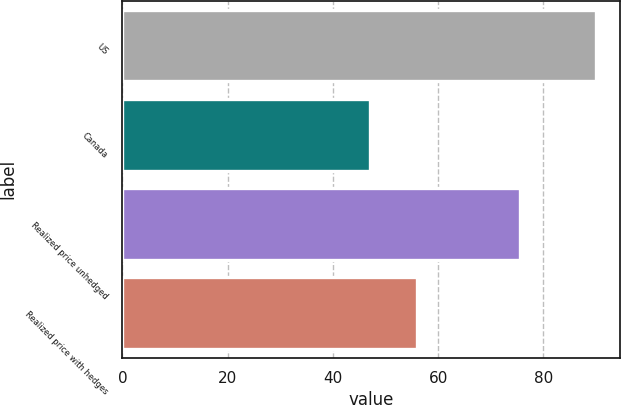Convert chart to OTSL. <chart><loc_0><loc_0><loc_500><loc_500><bar_chart><fcel>US<fcel>Canada<fcel>Realized price unhedged<fcel>Realized price with hedges<nl><fcel>90<fcel>47<fcel>75.6<fcel>56<nl></chart> 